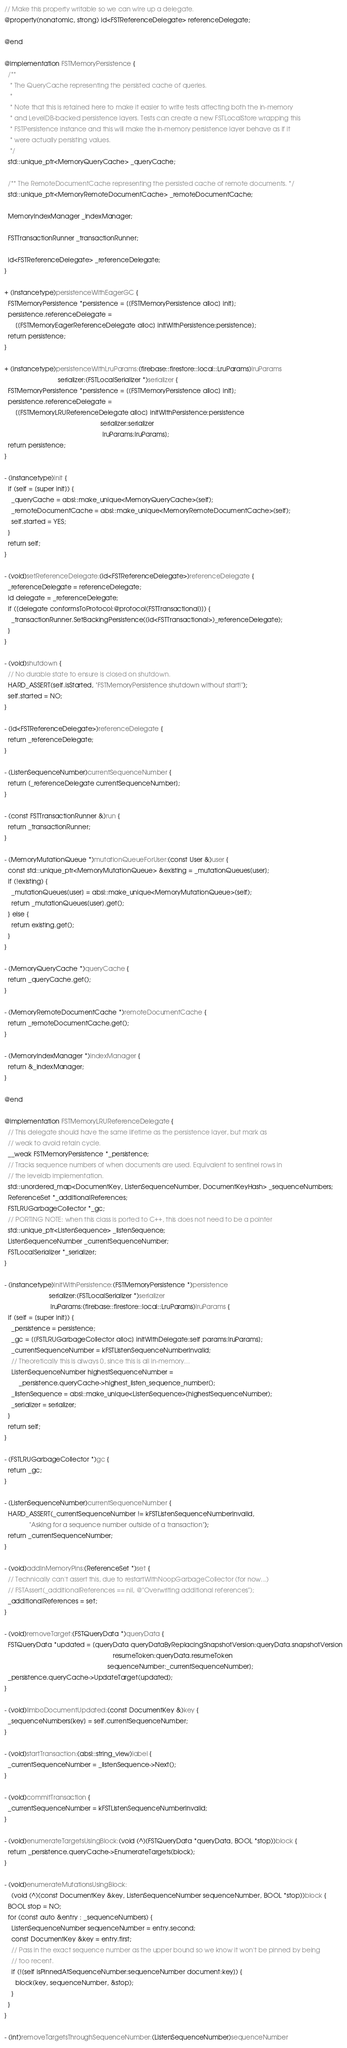Convert code to text. <code><loc_0><loc_0><loc_500><loc_500><_ObjectiveC_>// Make this property writable so we can wire up a delegate.
@property(nonatomic, strong) id<FSTReferenceDelegate> referenceDelegate;

@end

@implementation FSTMemoryPersistence {
  /**
   * The QueryCache representing the persisted cache of queries.
   *
   * Note that this is retained here to make it easier to write tests affecting both the in-memory
   * and LevelDB-backed persistence layers. Tests can create a new FSTLocalStore wrapping this
   * FSTPersistence instance and this will make the in-memory persistence layer behave as if it
   * were actually persisting values.
   */
  std::unique_ptr<MemoryQueryCache> _queryCache;

  /** The RemoteDocumentCache representing the persisted cache of remote documents. */
  std::unique_ptr<MemoryRemoteDocumentCache> _remoteDocumentCache;

  MemoryIndexManager _indexManager;

  FSTTransactionRunner _transactionRunner;

  id<FSTReferenceDelegate> _referenceDelegate;
}

+ (instancetype)persistenceWithEagerGC {
  FSTMemoryPersistence *persistence = [[FSTMemoryPersistence alloc] init];
  persistence.referenceDelegate =
      [[FSTMemoryEagerReferenceDelegate alloc] initWithPersistence:persistence];
  return persistence;
}

+ (instancetype)persistenceWithLruParams:(firebase::firestore::local::LruParams)lruParams
                              serializer:(FSTLocalSerializer *)serializer {
  FSTMemoryPersistence *persistence = [[FSTMemoryPersistence alloc] init];
  persistence.referenceDelegate =
      [[FSTMemoryLRUReferenceDelegate alloc] initWithPersistence:persistence
                                                      serializer:serializer
                                                       lruParams:lruParams];
  return persistence;
}

- (instancetype)init {
  if (self = [super init]) {
    _queryCache = absl::make_unique<MemoryQueryCache>(self);
    _remoteDocumentCache = absl::make_unique<MemoryRemoteDocumentCache>(self);
    self.started = YES;
  }
  return self;
}

- (void)setReferenceDelegate:(id<FSTReferenceDelegate>)referenceDelegate {
  _referenceDelegate = referenceDelegate;
  id delegate = _referenceDelegate;
  if ([delegate conformsToProtocol:@protocol(FSTTransactional)]) {
    _transactionRunner.SetBackingPersistence((id<FSTTransactional>)_referenceDelegate);
  }
}

- (void)shutdown {
  // No durable state to ensure is closed on shutdown.
  HARD_ASSERT(self.isStarted, "FSTMemoryPersistence shutdown without start!");
  self.started = NO;
}

- (id<FSTReferenceDelegate>)referenceDelegate {
  return _referenceDelegate;
}

- (ListenSequenceNumber)currentSequenceNumber {
  return [_referenceDelegate currentSequenceNumber];
}

- (const FSTTransactionRunner &)run {
  return _transactionRunner;
}

- (MemoryMutationQueue *)mutationQueueForUser:(const User &)user {
  const std::unique_ptr<MemoryMutationQueue> &existing = _mutationQueues[user];
  if (!existing) {
    _mutationQueues[user] = absl::make_unique<MemoryMutationQueue>(self);
    return _mutationQueues[user].get();
  } else {
    return existing.get();
  }
}

- (MemoryQueryCache *)queryCache {
  return _queryCache.get();
}

- (MemoryRemoteDocumentCache *)remoteDocumentCache {
  return _remoteDocumentCache.get();
}

- (MemoryIndexManager *)indexManager {
  return &_indexManager;
}

@end

@implementation FSTMemoryLRUReferenceDelegate {
  // This delegate should have the same lifetime as the persistence layer, but mark as
  // weak to avoid retain cycle.
  __weak FSTMemoryPersistence *_persistence;
  // Tracks sequence numbers of when documents are used. Equivalent to sentinel rows in
  // the leveldb implementation.
  std::unordered_map<DocumentKey, ListenSequenceNumber, DocumentKeyHash> _sequenceNumbers;
  ReferenceSet *_additionalReferences;
  FSTLRUGarbageCollector *_gc;
  // PORTING NOTE: when this class is ported to C++, this does not need to be a pointer
  std::unique_ptr<ListenSequence> _listenSequence;
  ListenSequenceNumber _currentSequenceNumber;
  FSTLocalSerializer *_serializer;
}

- (instancetype)initWithPersistence:(FSTMemoryPersistence *)persistence
                         serializer:(FSTLocalSerializer *)serializer
                          lruParams:(firebase::firestore::local::LruParams)lruParams {
  if (self = [super init]) {
    _persistence = persistence;
    _gc = [[FSTLRUGarbageCollector alloc] initWithDelegate:self params:lruParams];
    _currentSequenceNumber = kFSTListenSequenceNumberInvalid;
    // Theoretically this is always 0, since this is all in-memory...
    ListenSequenceNumber highestSequenceNumber =
        _persistence.queryCache->highest_listen_sequence_number();
    _listenSequence = absl::make_unique<ListenSequence>(highestSequenceNumber);
    _serializer = serializer;
  }
  return self;
}

- (FSTLRUGarbageCollector *)gc {
  return _gc;
}

- (ListenSequenceNumber)currentSequenceNumber {
  HARD_ASSERT(_currentSequenceNumber != kFSTListenSequenceNumberInvalid,
              "Asking for a sequence number outside of a transaction");
  return _currentSequenceNumber;
}

- (void)addInMemoryPins:(ReferenceSet *)set {
  // Technically can't assert this, due to restartWithNoopGarbageCollector (for now...)
  // FSTAssert(_additionalReferences == nil, @"Overwriting additional references");
  _additionalReferences = set;
}

- (void)removeTarget:(FSTQueryData *)queryData {
  FSTQueryData *updated = [queryData queryDataByReplacingSnapshotVersion:queryData.snapshotVersion
                                                             resumeToken:queryData.resumeToken
                                                          sequenceNumber:_currentSequenceNumber];
  _persistence.queryCache->UpdateTarget(updated);
}

- (void)limboDocumentUpdated:(const DocumentKey &)key {
  _sequenceNumbers[key] = self.currentSequenceNumber;
}

- (void)startTransaction:(absl::string_view)label {
  _currentSequenceNumber = _listenSequence->Next();
}

- (void)commitTransaction {
  _currentSequenceNumber = kFSTListenSequenceNumberInvalid;
}

- (void)enumerateTargetsUsingBlock:(void (^)(FSTQueryData *queryData, BOOL *stop))block {
  return _persistence.queryCache->EnumerateTargets(block);
}

- (void)enumerateMutationsUsingBlock:
    (void (^)(const DocumentKey &key, ListenSequenceNumber sequenceNumber, BOOL *stop))block {
  BOOL stop = NO;
  for (const auto &entry : _sequenceNumbers) {
    ListenSequenceNumber sequenceNumber = entry.second;
    const DocumentKey &key = entry.first;
    // Pass in the exact sequence number as the upper bound so we know it won't be pinned by being
    // too recent.
    if (![self isPinnedAtSequenceNumber:sequenceNumber document:key]) {
      block(key, sequenceNumber, &stop);
    }
  }
}

- (int)removeTargetsThroughSequenceNumber:(ListenSequenceNumber)sequenceNumber</code> 